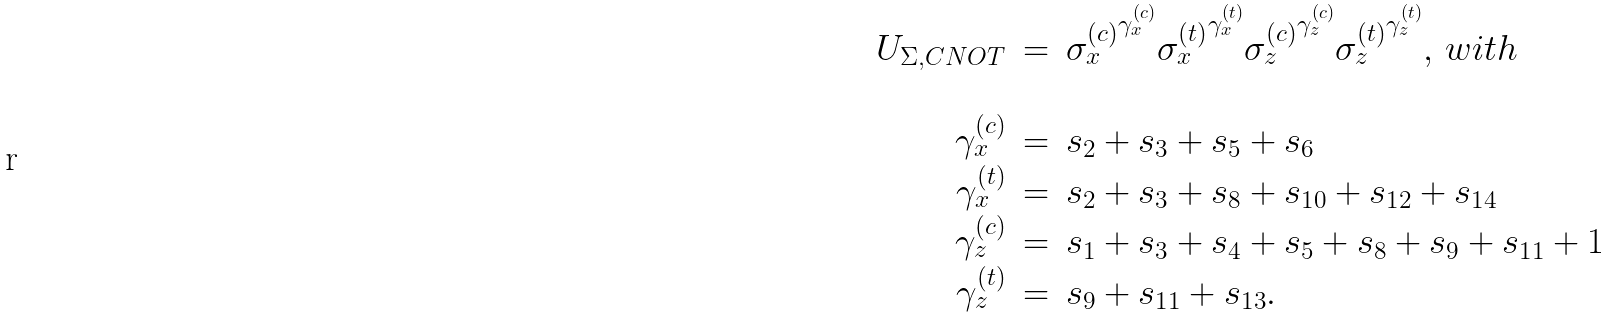Convert formula to latex. <formula><loc_0><loc_0><loc_500><loc_500>\begin{array} { r c l } U _ { \Sigma , C N O T } & = & { \sigma _ { x } ^ { ( c ) } } ^ { \gamma _ { x } ^ { ( c ) } } { \sigma _ { x } ^ { ( t ) } } ^ { \gamma _ { x } ^ { ( t ) } } { \sigma _ { z } ^ { ( c ) } } ^ { \gamma _ { z } ^ { ( c ) } } { \sigma _ { z } ^ { ( t ) } } ^ { \gamma _ { z } ^ { ( t ) } } , \, w i t h \\ & \\ { \gamma _ { x } ^ { ( c ) } } & = & { s } _ { 2 } + { s } _ { 3 } + { s } _ { 5 } + { s } _ { 6 } \\ { \gamma _ { x } ^ { ( t ) } } & = & { s } _ { 2 } + { s } _ { 3 } + { s } _ { 8 } + { s } _ { 1 0 } + { s } _ { 1 2 } + { s } _ { 1 4 } \\ { \gamma _ { z } ^ { ( c ) } } & = & { s } _ { 1 } + { s } _ { 3 } + { s } _ { 4 } + { s } _ { 5 } + { s } _ { 8 } + { s } _ { 9 } + { s } _ { 1 1 } + 1 \\ { \gamma _ { z } ^ { ( t ) } } & = & { s } _ { 9 } + { s } _ { 1 1 } + { s } _ { 1 3 } . \end{array}</formula> 